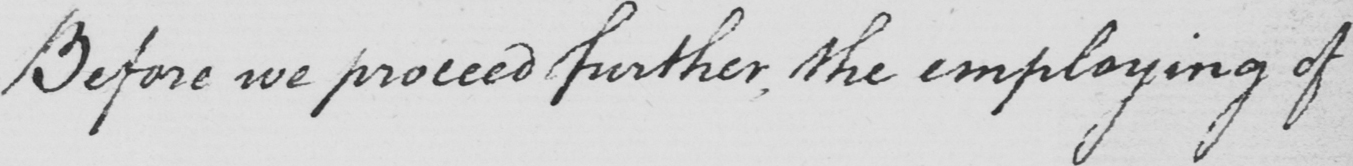What is written in this line of handwriting? Before we proceed further , the employing of 